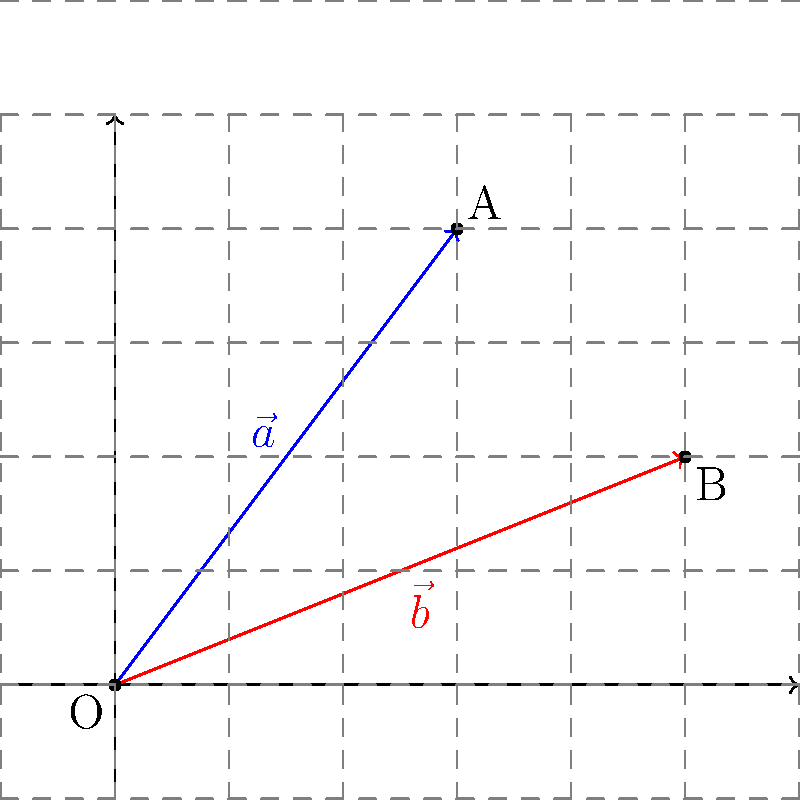In einem lokalisierten Benutzerinterface sollen zwei Textfelder optimal platziert werden. Die Positionen der Textfelder werden durch die Vektoren $\vec{a} = (3, 4)$ und $\vec{b} = (5, 2)$ repräsentiert. Um die Lesbarkeit zu verbessern, soll der Winkel zwischen den Textfeldern möglichst groß sein. Berechnen Sie den Kosinus des Winkels zwischen den beiden Vektoren mithilfe des Skalarprodukts. Runden Sie Ihr Ergebnis auf drei Dezimalstellen. Um den Kosinus des Winkels zwischen zwei Vektoren zu berechnen, verwenden wir die Formel für das Skalarprodukt:

$$\cos \theta = \frac{\vec{a} \cdot \vec{b}}{|\vec{a}| |\vec{b}|}$$

Schritte zur Lösung:

1. Berechnen des Skalarprodukts $\vec{a} \cdot \vec{b}$:
   $$\vec{a} \cdot \vec{b} = (3 \cdot 5) + (4 \cdot 2) = 15 + 8 = 23$$

2. Berechnen der Längen der Vektoren:
   $$|\vec{a}| = \sqrt{3^2 + 4^2} = \sqrt{9 + 16} = \sqrt{25} = 5$$
   $$|\vec{b}| = \sqrt{5^2 + 2^2} = \sqrt{25 + 4} = \sqrt{29}$$

3. Einsetzen in die Formel:
   $$\cos \theta = \frac{23}{5 \cdot \sqrt{29}}$$

4. Berechnen und Runden auf drei Dezimalstellen:
   $$\cos \theta \approx 0.855$$

Dieser Wert gibt den Kosinus des Winkels zwischen den beiden Vektoren an. Je kleiner dieser Wert ist, desto größer ist der Winkel zwischen den Textfeldern, was die Lesbarkeit verbessert.
Answer: 0.855 